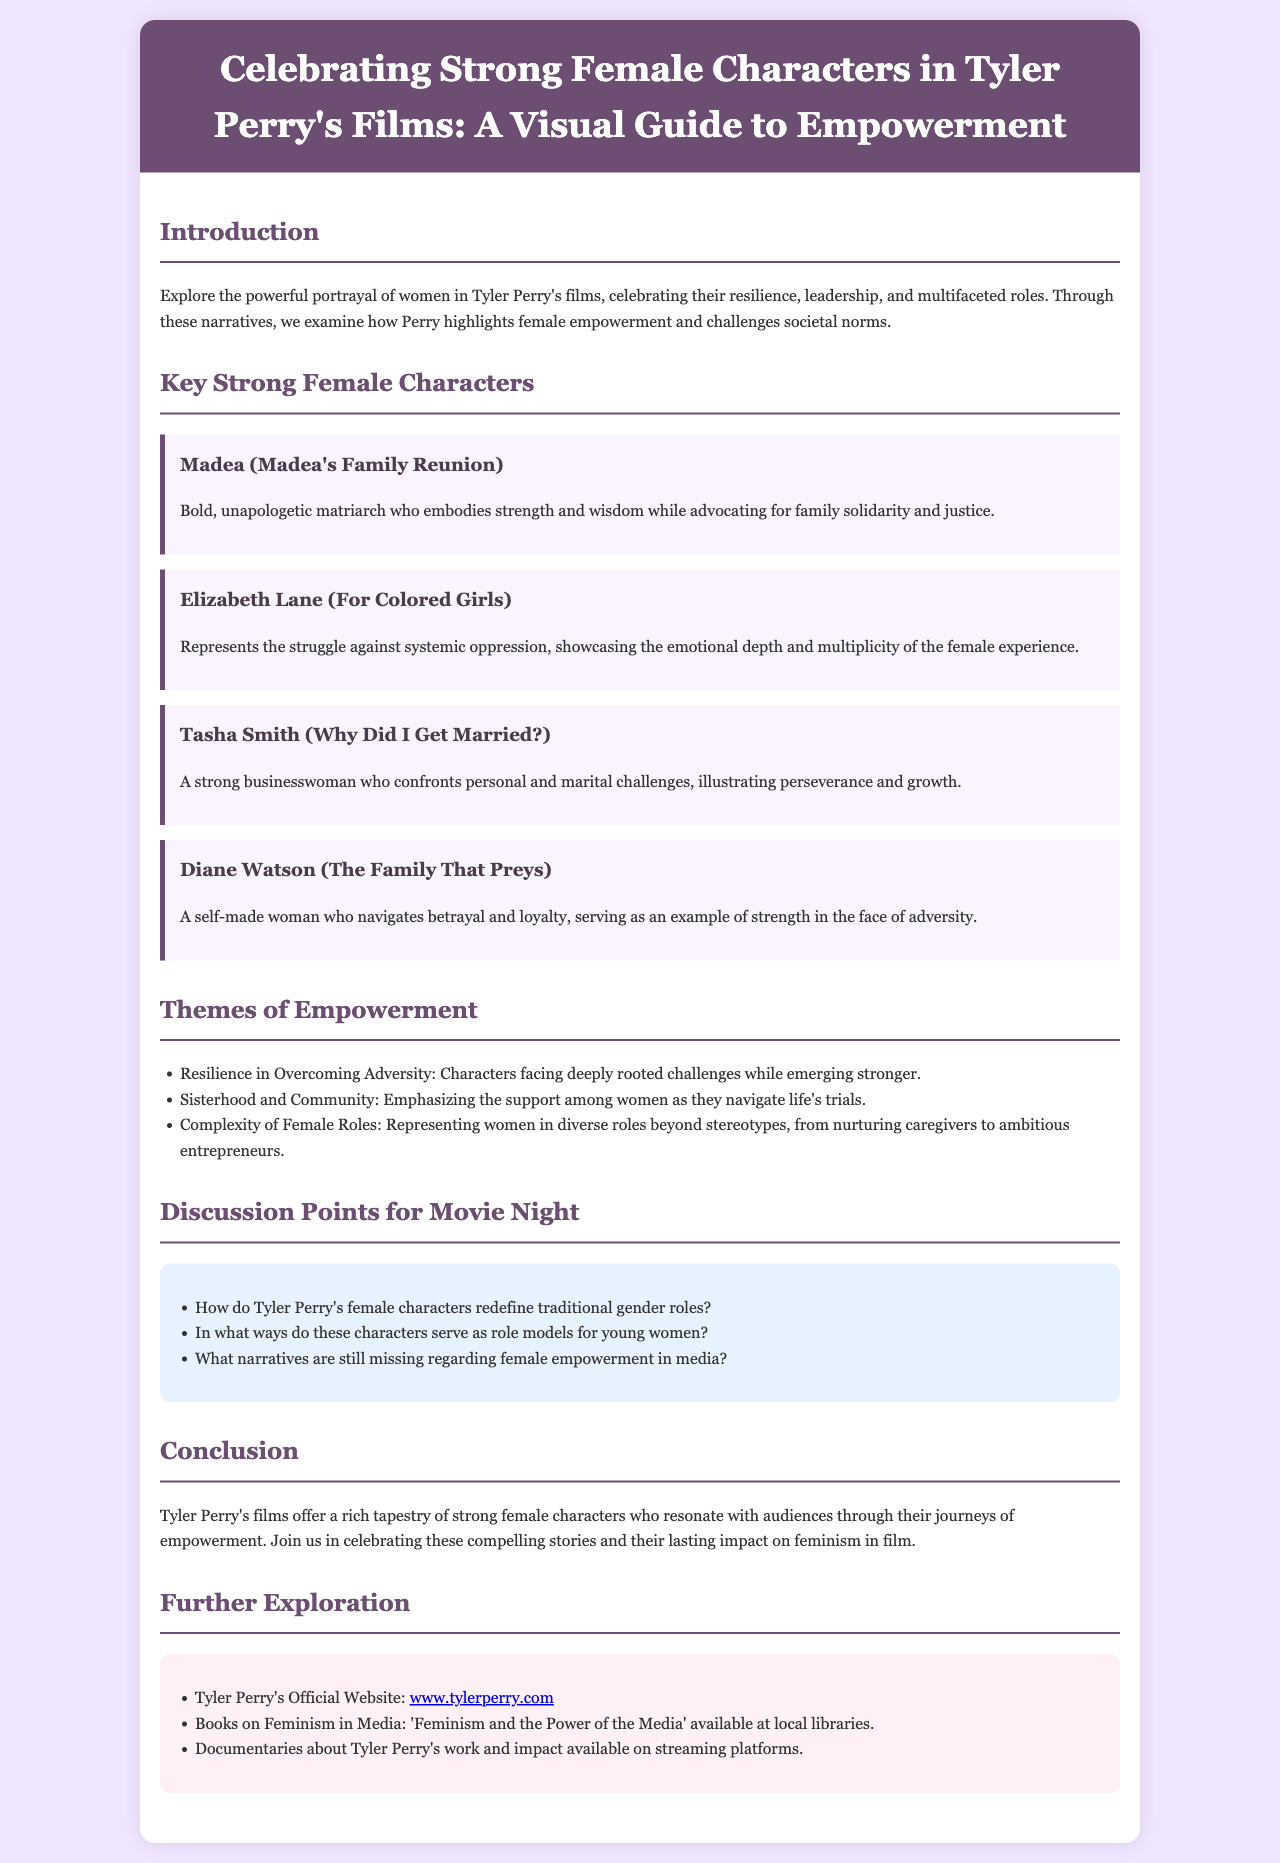what is the title of the brochure? The title of the brochure is presented in the header of the document, highlighting the focus on women in Tyler Perry's films.
Answer: Celebrating Strong Female Characters in Tyler Perry's Films: A Visual Guide to Empowerment who is the character represented in "Madea's Family Reunion"? The character associated with "Madea's Family Reunion" is mentioned in the section about strong female characters.
Answer: Madea what theme emphasizes support among women? This theme can be found in the list of empowerment themes, emphasizing the connection between women.
Answer: Sisterhood and Community which character represents the struggle against systemic oppression? This is one of the key strong female characters identified in the document, specifically linked to her film.
Answer: Elizabeth Lane how many key strong female characters are listed in the brochure? The document organizes characters in a section, detailing how many are highlighted.
Answer: Four what is a discussion point for movie night? The document provides specific questions related to female empowerment that can be discussed during movie night.
Answer: How do Tyler Perry's female characters redefine traditional gender roles? which website can be visited for more information about Tyler Perry? The resources section includes a link for more information about his work.
Answer: www.tylerperry.com who navigates betrayal and loyalty in "The Family That Preys"? This character's role is described in relation to navigating complex relationships within the film.
Answer: Diane Watson what type of matriarch is Madea? Described in the "Key Strong Female Characters" section, it highlights her traits and role.
Answer: Bold, unapologetic 